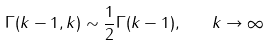Convert formula to latex. <formula><loc_0><loc_0><loc_500><loc_500>\Gamma ( k - 1 , k ) \sim \frac { 1 } { 2 } \Gamma ( k - 1 ) , \quad k \to \infty</formula> 